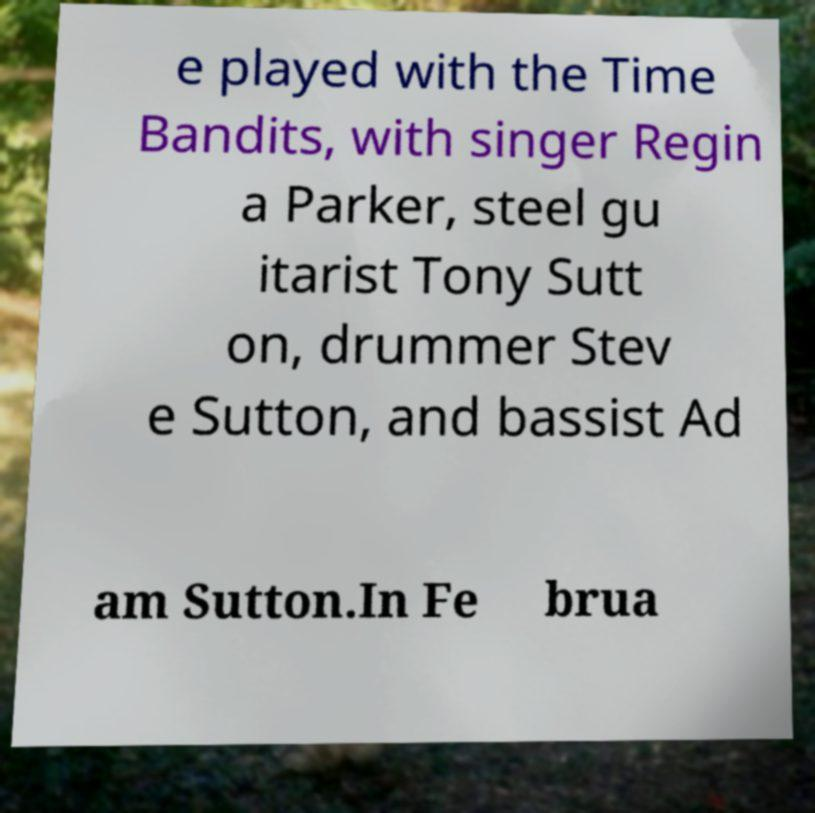What messages or text are displayed in this image? I need them in a readable, typed format. e played with the Time Bandits, with singer Regin a Parker, steel gu itarist Tony Sutt on, drummer Stev e Sutton, and bassist Ad am Sutton.In Fe brua 